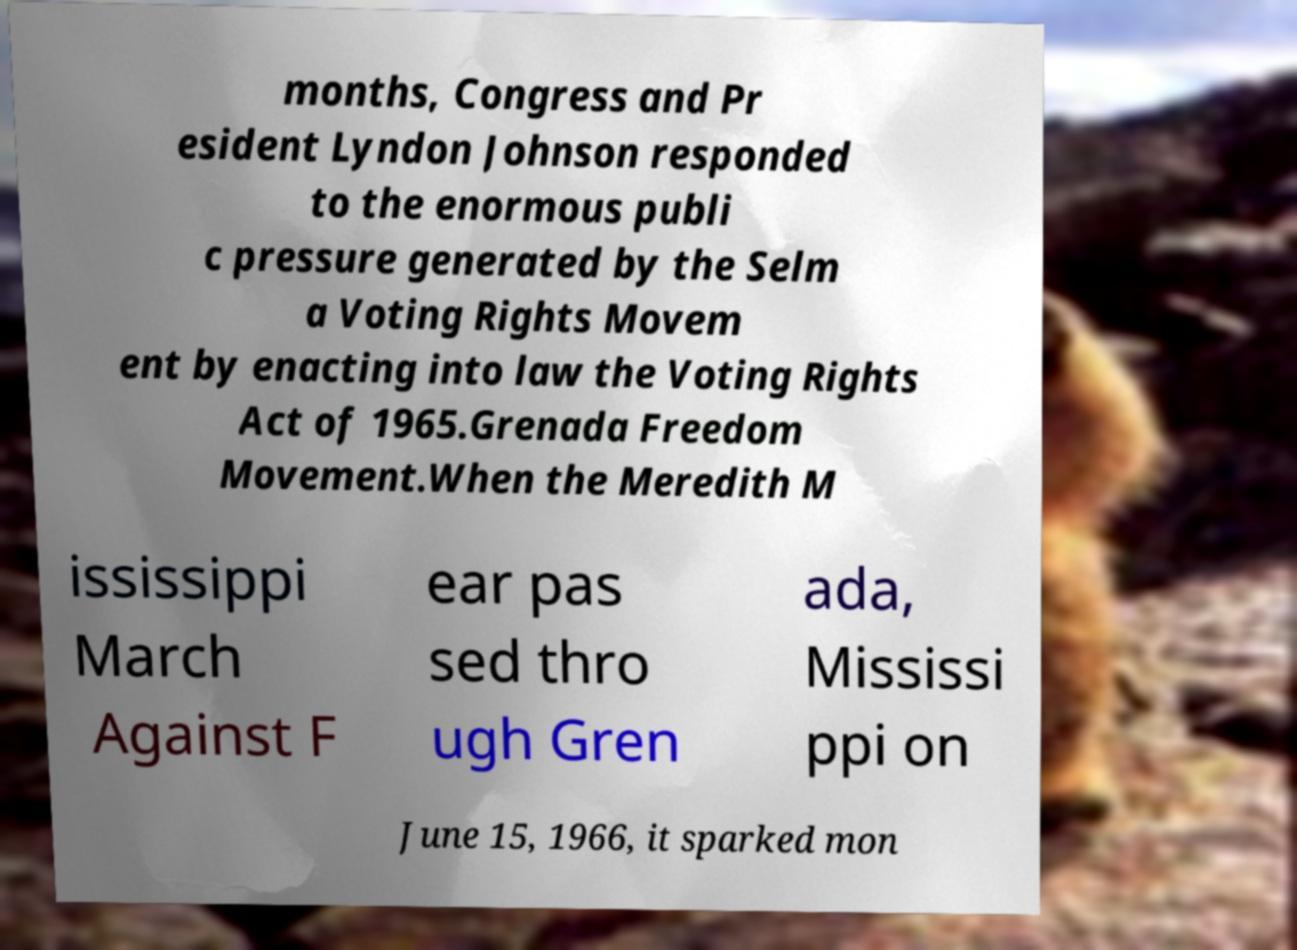Could you assist in decoding the text presented in this image and type it out clearly? months, Congress and Pr esident Lyndon Johnson responded to the enormous publi c pressure generated by the Selm a Voting Rights Movem ent by enacting into law the Voting Rights Act of 1965.Grenada Freedom Movement.When the Meredith M ississippi March Against F ear pas sed thro ugh Gren ada, Mississi ppi on June 15, 1966, it sparked mon 